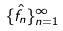<formula> <loc_0><loc_0><loc_500><loc_500>\{ \hat { f } _ { n } \} _ { n = 1 } ^ { \infty }</formula> 